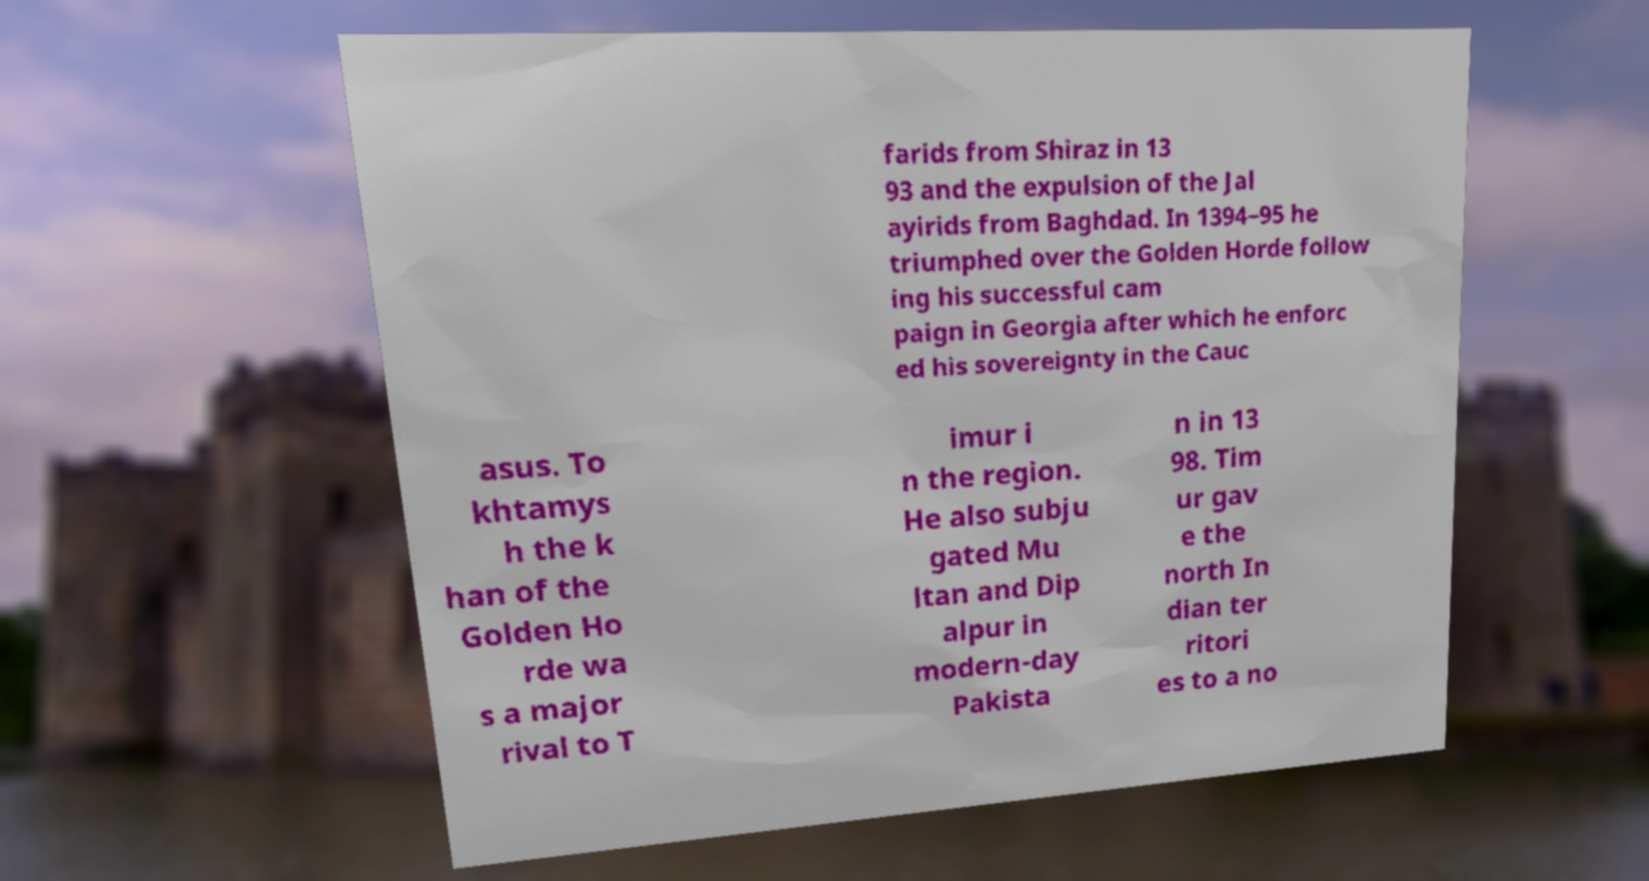Please read and relay the text visible in this image. What does it say? farids from Shiraz in 13 93 and the expulsion of the Jal ayirids from Baghdad. In 1394–95 he triumphed over the Golden Horde follow ing his successful cam paign in Georgia after which he enforc ed his sovereignty in the Cauc asus. To khtamys h the k han of the Golden Ho rde wa s a major rival to T imur i n the region. He also subju gated Mu ltan and Dip alpur in modern-day Pakista n in 13 98. Tim ur gav e the north In dian ter ritori es to a no 